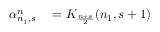Convert formula to latex. <formula><loc_0><loc_0><loc_500><loc_500>\begin{array} { r l } { \alpha _ { n _ { 1 } , s } ^ { n } } & = K _ { \frac { n + s } { 2 } } ( n _ { 1 } , s + 1 ) } \end{array}</formula> 